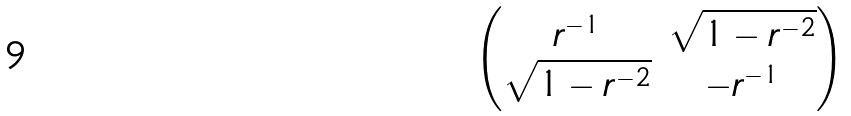Convert formula to latex. <formula><loc_0><loc_0><loc_500><loc_500>\begin{pmatrix} r ^ { - 1 } & \sqrt { 1 - r ^ { - 2 } } \\ \sqrt { 1 - r ^ { - 2 } } & - r ^ { - 1 } \end{pmatrix}</formula> 